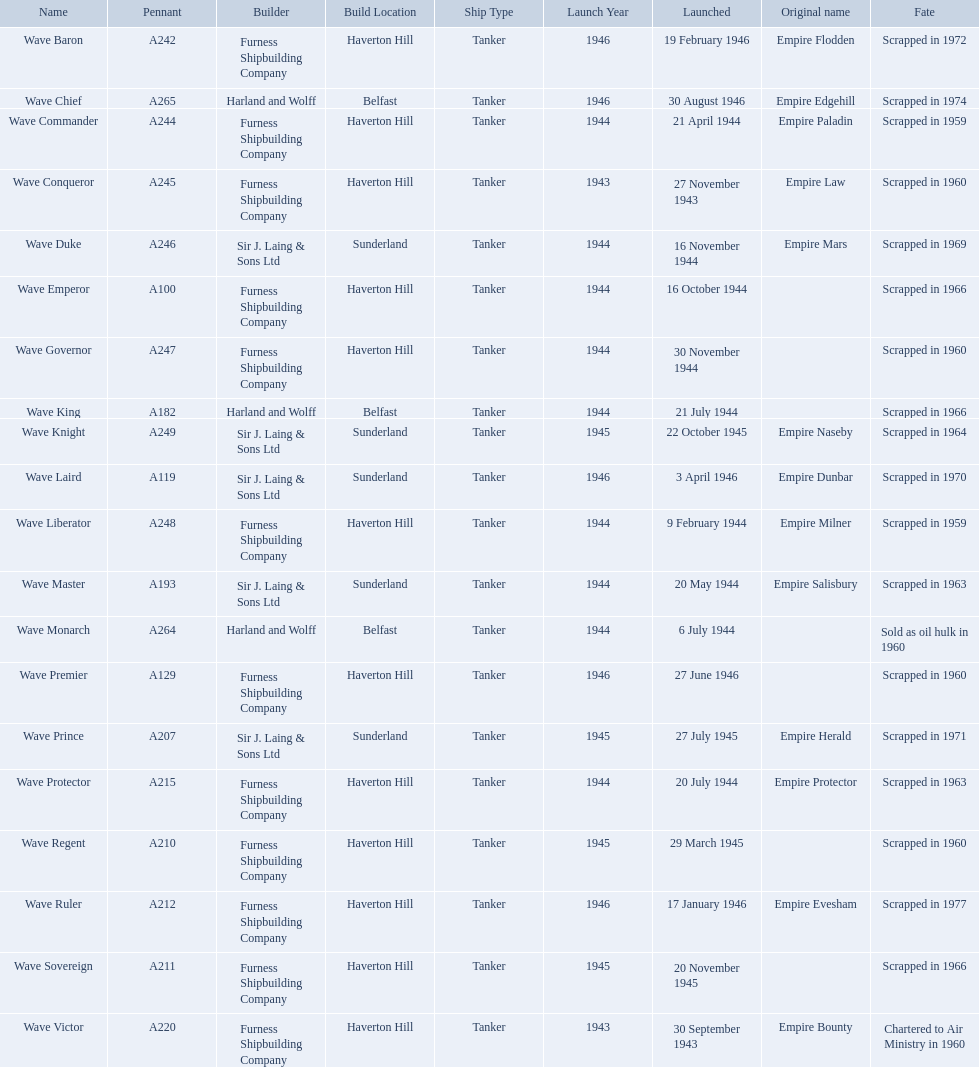What year was the wave victor launched? 30 September 1943. What other ship was launched in 1943? Wave Conqueror. Write the full table. {'header': ['Name', 'Pennant', 'Builder', 'Build Location', 'Ship Type', 'Launch Year', 'Launched', 'Original name', 'Fate'], 'rows': [['Wave Baron', 'A242', 'Furness Shipbuilding Company', 'Haverton Hill', 'Tanker', '1946', '19 February 1946', 'Empire Flodden', 'Scrapped in 1972'], ['Wave Chief', 'A265', 'Harland and Wolff', 'Belfast', 'Tanker', '1946', '30 August 1946', 'Empire Edgehill', 'Scrapped in 1974'], ['Wave Commander', 'A244', 'Furness Shipbuilding Company', 'Haverton Hill', 'Tanker', '1944', '21 April 1944', 'Empire Paladin', 'Scrapped in 1959'], ['Wave Conqueror', 'A245', 'Furness Shipbuilding Company', 'Haverton Hill', 'Tanker', '1943', '27 November 1943', 'Empire Law', 'Scrapped in 1960'], ['Wave Duke', 'A246', 'Sir J. Laing & Sons Ltd', 'Sunderland', 'Tanker', '1944', '16 November 1944', 'Empire Mars', 'Scrapped in 1969'], ['Wave Emperor', 'A100', 'Furness Shipbuilding Company', 'Haverton Hill', 'Tanker', '1944', '16 October 1944', '', 'Scrapped in 1966'], ['Wave Governor', 'A247', 'Furness Shipbuilding Company', 'Haverton Hill', 'Tanker', '1944', '30 November 1944', '', 'Scrapped in 1960'], ['Wave King', 'A182', 'Harland and Wolff', 'Belfast', 'Tanker', '1944', '21 July 1944', '', 'Scrapped in 1966'], ['Wave Knight', 'A249', 'Sir J. Laing & Sons Ltd', 'Sunderland', 'Tanker', '1945', '22 October 1945', 'Empire Naseby', 'Scrapped in 1964'], ['Wave Laird', 'A119', 'Sir J. Laing & Sons Ltd', 'Sunderland', 'Tanker', '1946', '3 April 1946', 'Empire Dunbar', 'Scrapped in 1970'], ['Wave Liberator', 'A248', 'Furness Shipbuilding Company', 'Haverton Hill', 'Tanker', '1944', '9 February 1944', 'Empire Milner', 'Scrapped in 1959'], ['Wave Master', 'A193', 'Sir J. Laing & Sons Ltd', 'Sunderland', 'Tanker', '1944', '20 May 1944', 'Empire Salisbury', 'Scrapped in 1963'], ['Wave Monarch', 'A264', 'Harland and Wolff', 'Belfast', 'Tanker', '1944', '6 July 1944', '', 'Sold as oil hulk in 1960'], ['Wave Premier', 'A129', 'Furness Shipbuilding Company', 'Haverton Hill', 'Tanker', '1946', '27 June 1946', '', 'Scrapped in 1960'], ['Wave Prince', 'A207', 'Sir J. Laing & Sons Ltd', 'Sunderland', 'Tanker', '1945', '27 July 1945', 'Empire Herald', 'Scrapped in 1971'], ['Wave Protector', 'A215', 'Furness Shipbuilding Company', 'Haverton Hill', 'Tanker', '1944', '20 July 1944', 'Empire Protector', 'Scrapped in 1963'], ['Wave Regent', 'A210', 'Furness Shipbuilding Company', 'Haverton Hill', 'Tanker', '1945', '29 March 1945', '', 'Scrapped in 1960'], ['Wave Ruler', 'A212', 'Furness Shipbuilding Company', 'Haverton Hill', 'Tanker', '1946', '17 January 1946', 'Empire Evesham', 'Scrapped in 1977'], ['Wave Sovereign', 'A211', 'Furness Shipbuilding Company', 'Haverton Hill', 'Tanker', '1945', '20 November 1945', '', 'Scrapped in 1966'], ['Wave Victor', 'A220', 'Furness Shipbuilding Company', 'Haverton Hill', 'Tanker', '1943', '30 September 1943', 'Empire Bounty', 'Chartered to Air Ministry in 1960']]} 